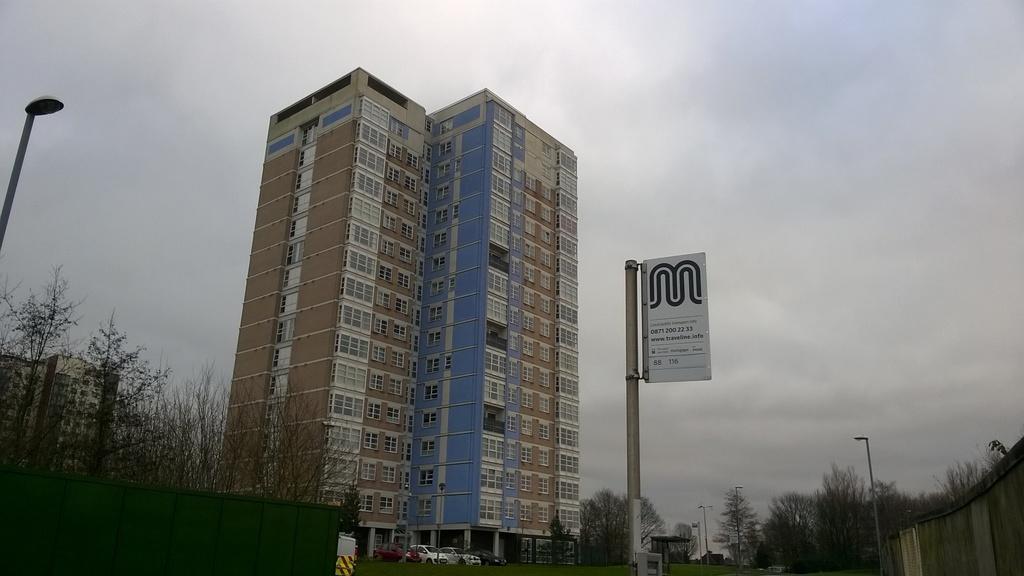Can you describe this image briefly? In this image there are buildings, trees, lamp posts, sign boards, cars and wooden fencing. 